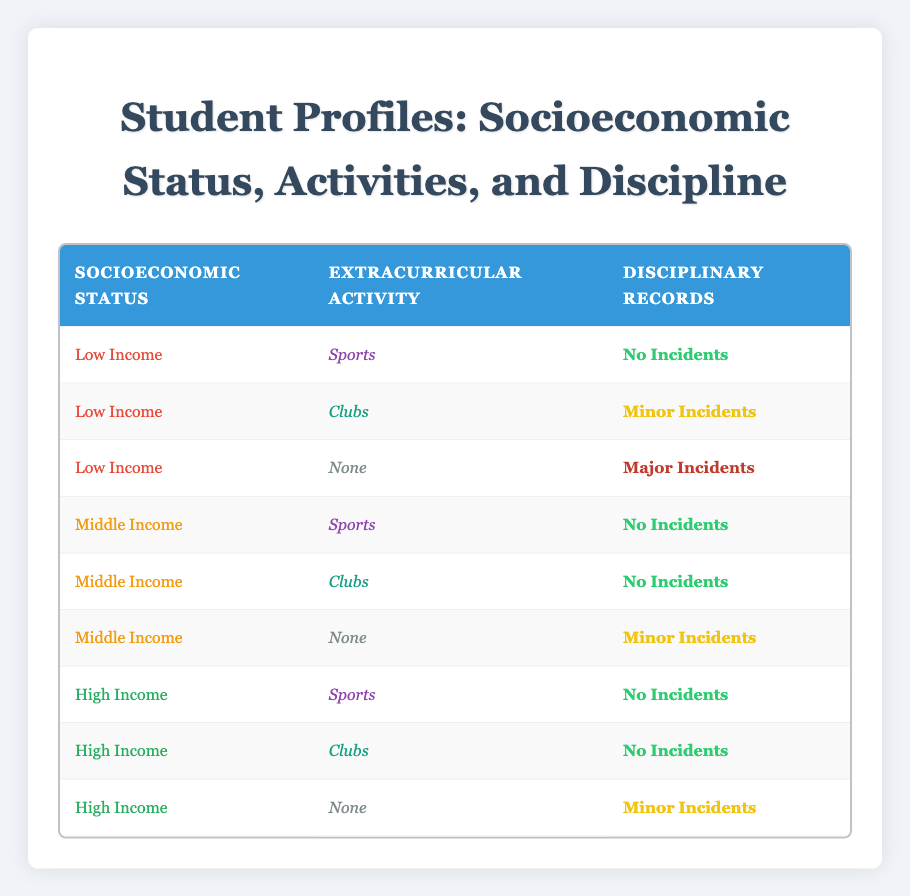What is the number of low-income students who have disciplinary incidents? There is one low-income student with major incidents and one with minor incidents. Therefore, the total number of low-income students with disciplinary incidents is 1 (Major Incidents) + 1 (Minor Incidents) = 2.
Answer: 2 What type of extracurricular activity do middle-income students participate in the least? Middle-income students have no incidents for sports and clubs but have minor incidents for "None." Thus, they participate in "None" the least, which corresponds to minor incidents.
Answer: None How many students with no incidents belong to the high-income category? There are three students in the high-income category, all of whom have no incidents according to the table.
Answer: 3 Is there any student from a low-income background who is involved in clubs with major incidents? According to the table, there are no students from a low-income background involved in clubs with major incidents. The low-income student with clubs has minor incidents.
Answer: No What is the ratio of students with no incidents to those with major incidents among all socioeconomic statuses? The total number of students with no incidents is 6 (3 from high income, 2 from middle income, 1 from low income). The only student with major incidents is 1 from low income. Therefore, the ratio is 6:1.
Answer: 6:1 How many students from different socioeconomic statuses face minor incidents? One low-income student (clubs) and two high-income students (none) experience minor incidents, totalling three students (1 from low income and 2 from high income).
Answer: 3 What percentage of low-income students has no incidents versus those who have major incidents? There is 1 low-income student with no incidents and 1 with major incidents. Therefore, the percentage of students with no incidents is (1/3) * 100 = 33.33%, and those with major incidents is (1/3) * 100 = 33.33%.
Answer: 33.33% How many students participate in sports across all socioeconomic statuses? Low-income (1), middle-income (1), and high-income (1) students participate in sports, resulting in a total of 3 students participating in sports.
Answer: 3 Is it true that all high-income students have no incidents? Yes, based on the table, all high-income students have no incidents. Therefore, the statement is true.
Answer: Yes 